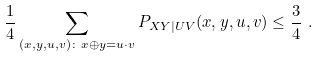Convert formula to latex. <formula><loc_0><loc_0><loc_500><loc_500>\frac { 1 } { 4 } \sum _ { ( x , y , u , v ) \colon x \oplus y = u \cdot v } P _ { X Y | U V } ( x , y , u , v ) & \leq \frac { 3 } { 4 } \ .</formula> 